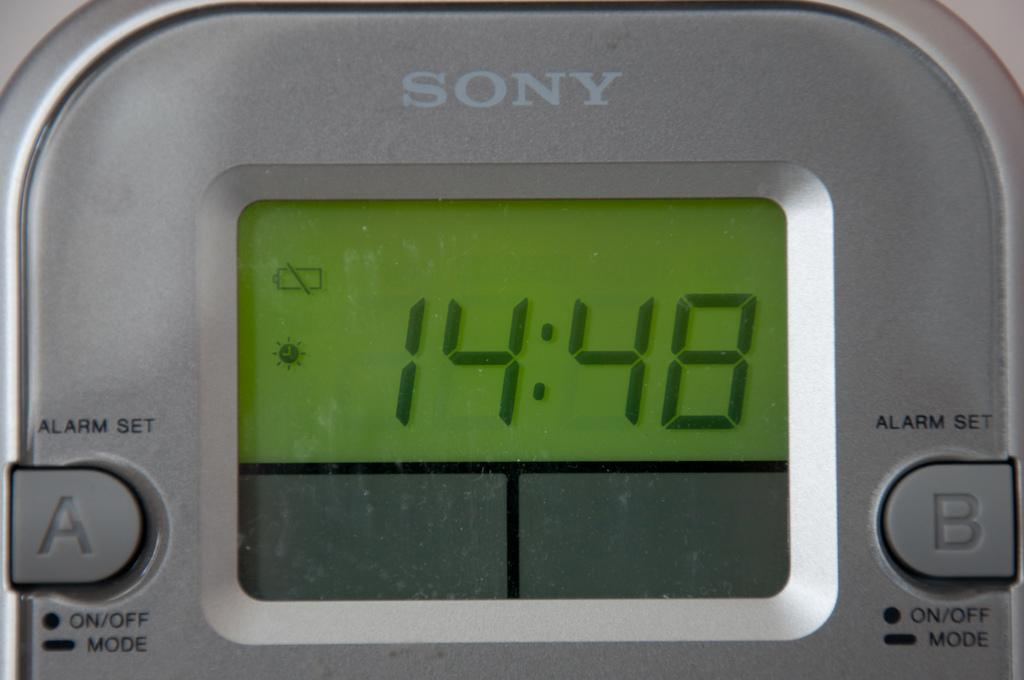Provide a one-sentence caption for the provided image. A Sony alarm clock that reads 14:48 on the screen. 